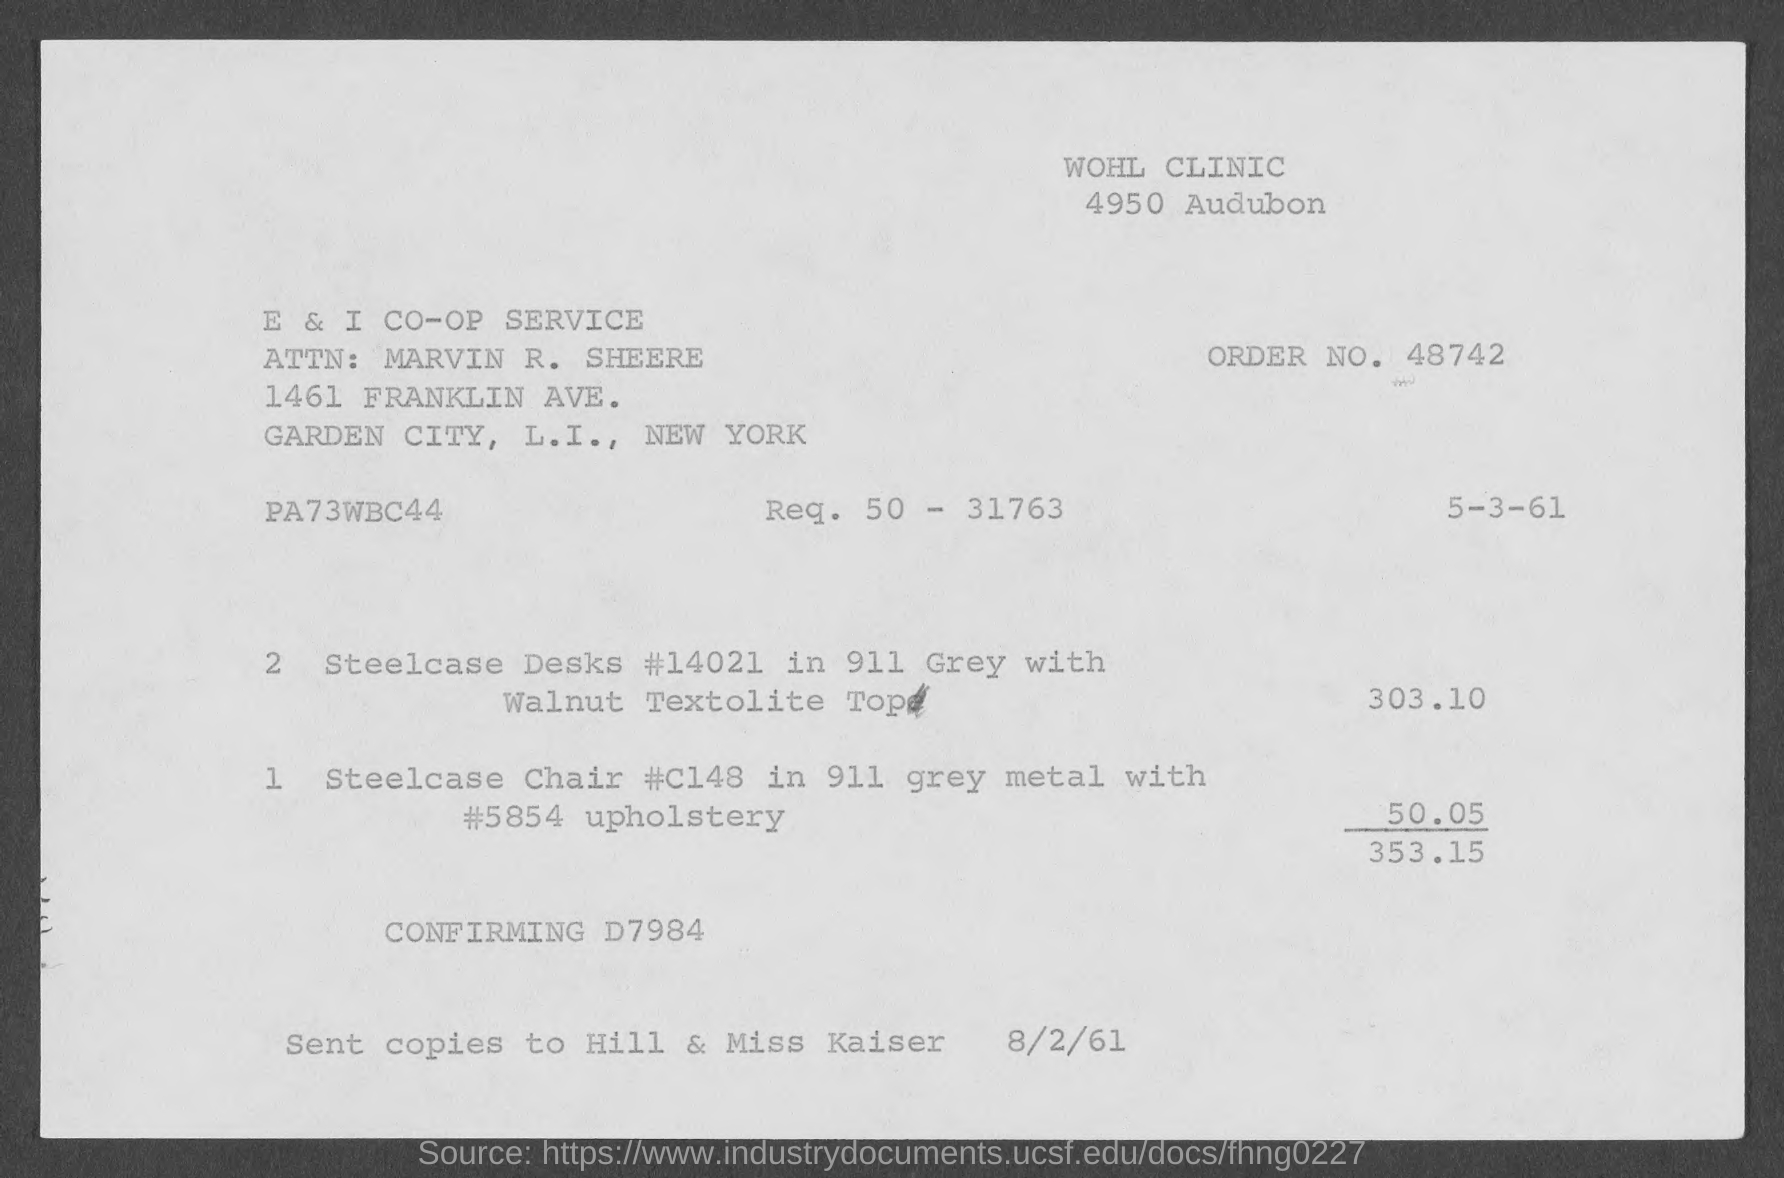What is the Order No. ?
Your answer should be compact. 48742. What is the total amount of the bill ?
Provide a short and direct response. 353.15. How much is the price of the steelcase Desks ?
Your answer should be very brief. 303.10. How much is the price of the Steelcase Chair ?
Make the answer very short. 50.05. 